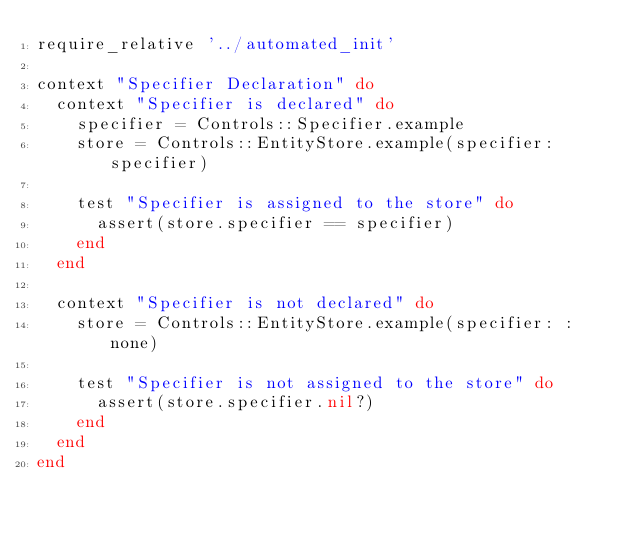Convert code to text. <code><loc_0><loc_0><loc_500><loc_500><_Ruby_>require_relative '../automated_init'

context "Specifier Declaration" do
  context "Specifier is declared" do
    specifier = Controls::Specifier.example
    store = Controls::EntityStore.example(specifier: specifier)

    test "Specifier is assigned to the store" do
      assert(store.specifier == specifier)
    end
  end

  context "Specifier is not declared" do
    store = Controls::EntityStore.example(specifier: :none)

    test "Specifier is not assigned to the store" do
      assert(store.specifier.nil?)
    end
  end
end
</code> 